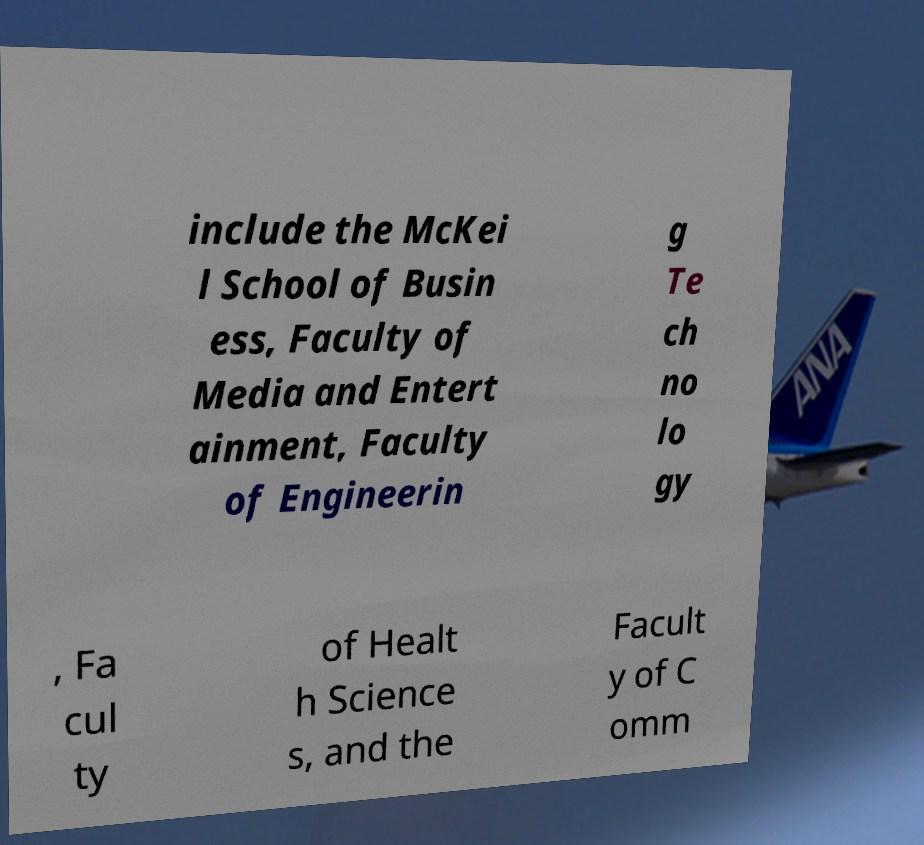What messages or text are displayed in this image? I need them in a readable, typed format. include the McKei l School of Busin ess, Faculty of Media and Entert ainment, Faculty of Engineerin g Te ch no lo gy , Fa cul ty of Healt h Science s, and the Facult y of C omm 